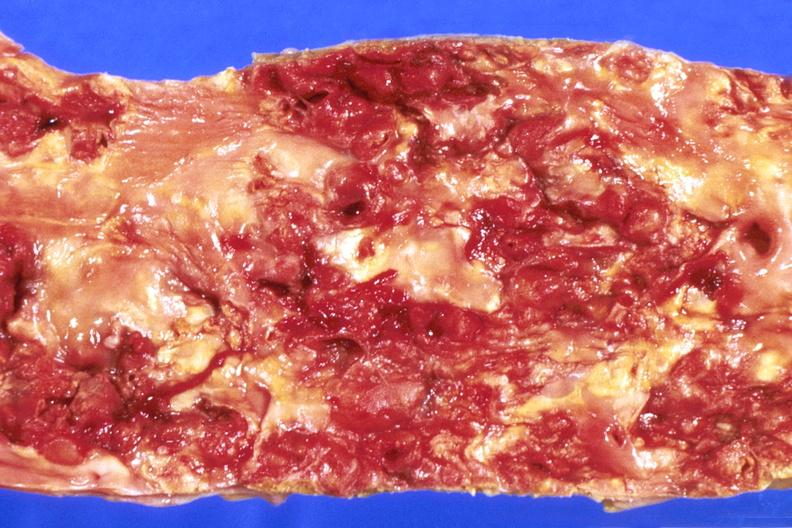s cardiovascular present?
Answer the question using a single word or phrase. Yes 